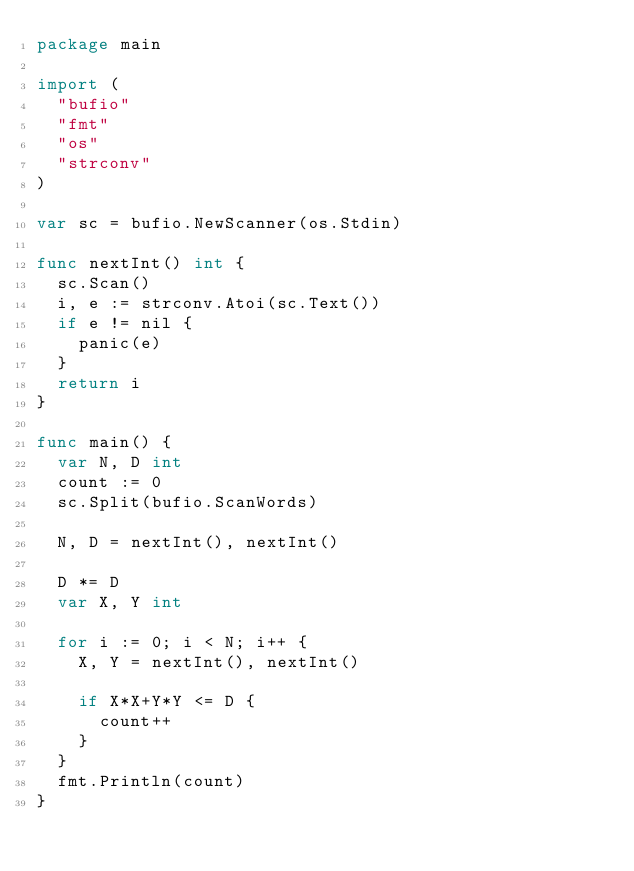<code> <loc_0><loc_0><loc_500><loc_500><_Go_>package main

import (
	"bufio"
	"fmt"
	"os"
	"strconv"
)

var sc = bufio.NewScanner(os.Stdin)

func nextInt() int {
	sc.Scan()
	i, e := strconv.Atoi(sc.Text())
	if e != nil {
		panic(e)
	}
	return i
}

func main() {
	var N, D int
	count := 0
	sc.Split(bufio.ScanWords)

	N, D = nextInt(), nextInt()

	D *= D
	var X, Y int

	for i := 0; i < N; i++ {
		X, Y = nextInt(), nextInt()

		if X*X+Y*Y <= D {
			count++
		}
	}
	fmt.Println(count)
}
</code> 